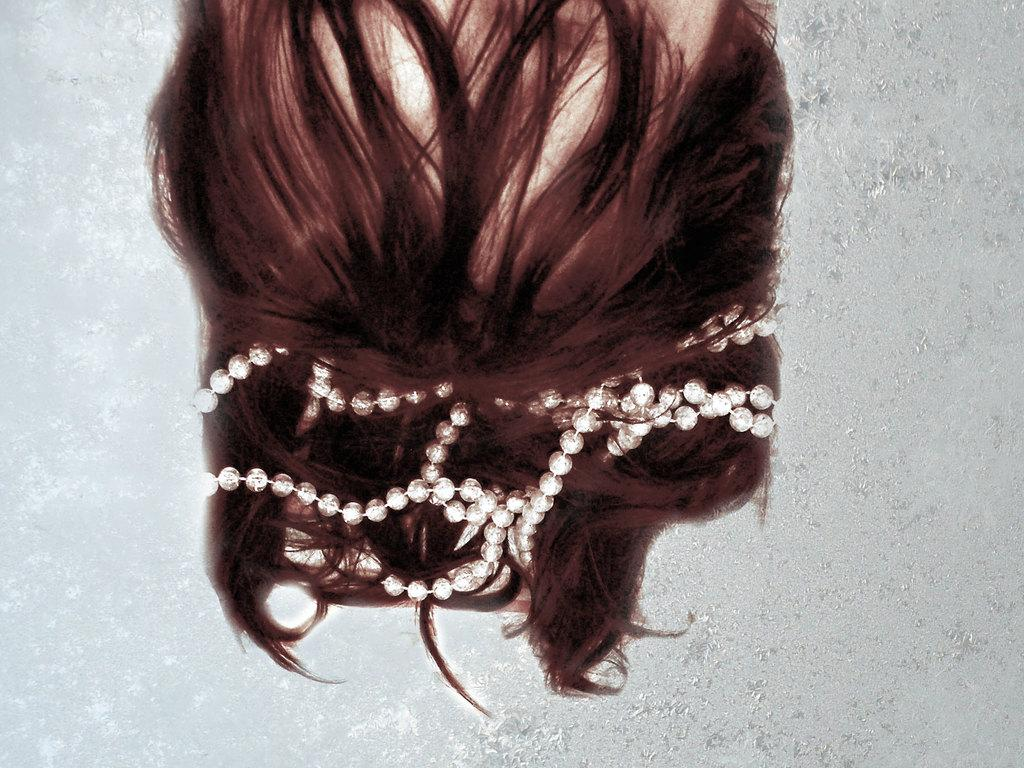What is the main subject of the image? There is a person's head in the image. What can be seen on the person's hair? The person has a hair accessory on their hair. What is visible in the background of the image? There is a wall visible in the background of the image. What is the current argument about in the image? There is no argument present in the image; it features a person's head with a hair accessory and a wall in the background. Is the person in the image in prison? There is no indication in the image that the person is in prison. 